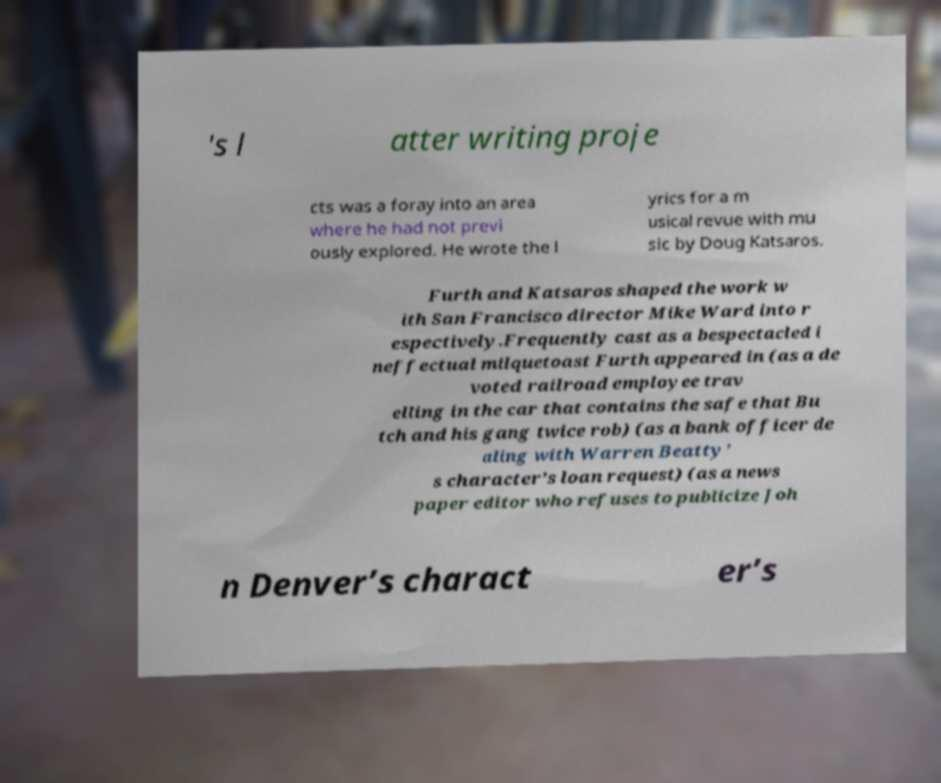Can you read and provide the text displayed in the image?This photo seems to have some interesting text. Can you extract and type it out for me? 's l atter writing proje cts was a foray into an area where he had not previ ously explored. He wrote the l yrics for a m usical revue with mu sic by Doug Katsaros. Furth and Katsaros shaped the work w ith San Francisco director Mike Ward into r espectively.Frequently cast as a bespectacled i neffectual milquetoast Furth appeared in (as a de voted railroad employee trav elling in the car that contains the safe that Bu tch and his gang twice rob) (as a bank officer de aling with Warren Beatty’ s character’s loan request) (as a news paper editor who refuses to publicize Joh n Denver’s charact er’s 